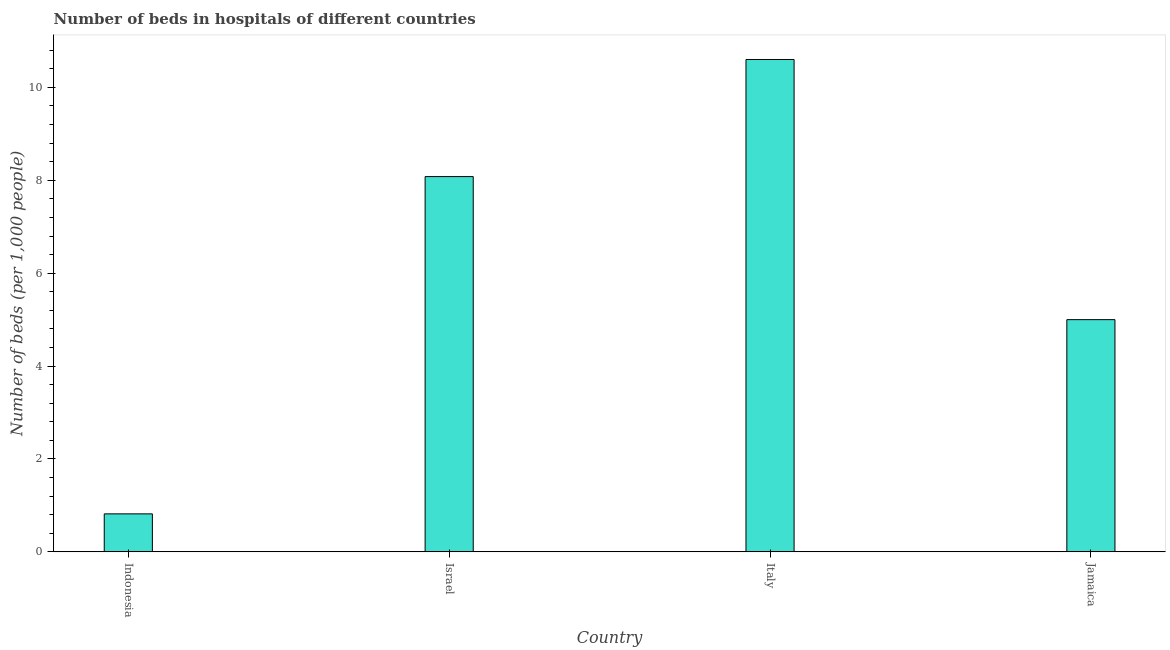Does the graph contain any zero values?
Your answer should be compact. No. Does the graph contain grids?
Keep it short and to the point. No. What is the title of the graph?
Your answer should be very brief. Number of beds in hospitals of different countries. What is the label or title of the Y-axis?
Your answer should be very brief. Number of beds (per 1,0 people). What is the number of hospital beds in Israel?
Offer a very short reply. 8.08. Across all countries, what is the maximum number of hospital beds?
Keep it short and to the point. 10.6. Across all countries, what is the minimum number of hospital beds?
Offer a terse response. 0.82. In which country was the number of hospital beds minimum?
Ensure brevity in your answer.  Indonesia. What is the sum of the number of hospital beds?
Make the answer very short. 24.5. What is the difference between the number of hospital beds in Indonesia and Jamaica?
Offer a very short reply. -4.18. What is the average number of hospital beds per country?
Your answer should be compact. 6.12. What is the median number of hospital beds?
Your answer should be compact. 6.54. What is the ratio of the number of hospital beds in Israel to that in Italy?
Your response must be concise. 0.76. Is the number of hospital beds in Israel less than that in Jamaica?
Keep it short and to the point. No. Is the difference between the number of hospital beds in Israel and Italy greater than the difference between any two countries?
Offer a very short reply. No. What is the difference between the highest and the second highest number of hospital beds?
Make the answer very short. 2.52. Is the sum of the number of hospital beds in Israel and Italy greater than the maximum number of hospital beds across all countries?
Ensure brevity in your answer.  Yes. What is the difference between the highest and the lowest number of hospital beds?
Provide a succinct answer. 9.78. How many countries are there in the graph?
Ensure brevity in your answer.  4. What is the difference between two consecutive major ticks on the Y-axis?
Offer a terse response. 2. Are the values on the major ticks of Y-axis written in scientific E-notation?
Offer a very short reply. No. What is the Number of beds (per 1,000 people) in Indonesia?
Give a very brief answer. 0.82. What is the Number of beds (per 1,000 people) in Israel?
Your answer should be compact. 8.08. What is the Number of beds (per 1,000 people) in Italy?
Ensure brevity in your answer.  10.6. What is the Number of beds (per 1,000 people) in Jamaica?
Your response must be concise. 5. What is the difference between the Number of beds (per 1,000 people) in Indonesia and Israel?
Give a very brief answer. -7.26. What is the difference between the Number of beds (per 1,000 people) in Indonesia and Italy?
Provide a succinct answer. -9.78. What is the difference between the Number of beds (per 1,000 people) in Indonesia and Jamaica?
Offer a terse response. -4.18. What is the difference between the Number of beds (per 1,000 people) in Israel and Italy?
Your answer should be compact. -2.52. What is the difference between the Number of beds (per 1,000 people) in Israel and Jamaica?
Ensure brevity in your answer.  3.08. What is the difference between the Number of beds (per 1,000 people) in Italy and Jamaica?
Ensure brevity in your answer.  5.6. What is the ratio of the Number of beds (per 1,000 people) in Indonesia to that in Israel?
Offer a terse response. 0.1. What is the ratio of the Number of beds (per 1,000 people) in Indonesia to that in Italy?
Make the answer very short. 0.08. What is the ratio of the Number of beds (per 1,000 people) in Indonesia to that in Jamaica?
Offer a terse response. 0.16. What is the ratio of the Number of beds (per 1,000 people) in Israel to that in Italy?
Your answer should be compact. 0.76. What is the ratio of the Number of beds (per 1,000 people) in Israel to that in Jamaica?
Give a very brief answer. 1.62. What is the ratio of the Number of beds (per 1,000 people) in Italy to that in Jamaica?
Ensure brevity in your answer.  2.12. 